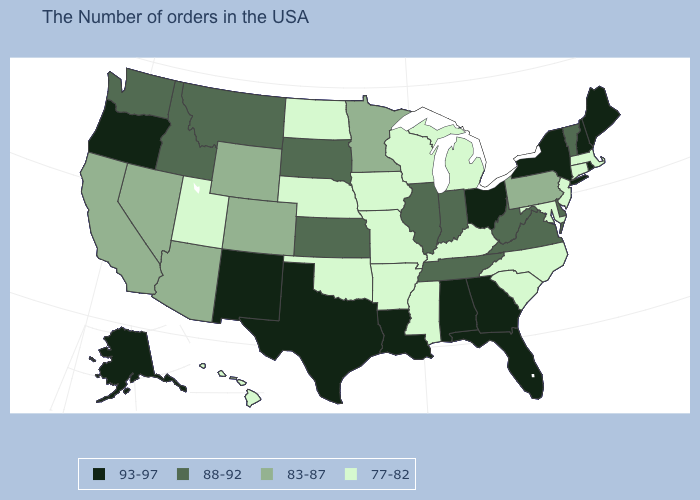What is the value of Maine?
Keep it brief. 93-97. What is the value of South Carolina?
Quick response, please. 77-82. What is the highest value in the USA?
Quick response, please. 93-97. Does the first symbol in the legend represent the smallest category?
Concise answer only. No. Name the states that have a value in the range 77-82?
Keep it brief. Massachusetts, Connecticut, New Jersey, Maryland, North Carolina, South Carolina, Michigan, Kentucky, Wisconsin, Mississippi, Missouri, Arkansas, Iowa, Nebraska, Oklahoma, North Dakota, Utah, Hawaii. Does North Dakota have the same value as West Virginia?
Be succinct. No. Which states have the lowest value in the USA?
Give a very brief answer. Massachusetts, Connecticut, New Jersey, Maryland, North Carolina, South Carolina, Michigan, Kentucky, Wisconsin, Mississippi, Missouri, Arkansas, Iowa, Nebraska, Oklahoma, North Dakota, Utah, Hawaii. What is the value of New Jersey?
Quick response, please. 77-82. Does the map have missing data?
Concise answer only. No. Does Massachusetts have the lowest value in the Northeast?
Be succinct. Yes. What is the value of South Dakota?
Concise answer only. 88-92. What is the highest value in states that border Louisiana?
Give a very brief answer. 93-97. Name the states that have a value in the range 88-92?
Quick response, please. Vermont, Delaware, Virginia, West Virginia, Indiana, Tennessee, Illinois, Kansas, South Dakota, Montana, Idaho, Washington. Which states have the lowest value in the West?
Give a very brief answer. Utah, Hawaii. Name the states that have a value in the range 88-92?
Be succinct. Vermont, Delaware, Virginia, West Virginia, Indiana, Tennessee, Illinois, Kansas, South Dakota, Montana, Idaho, Washington. 